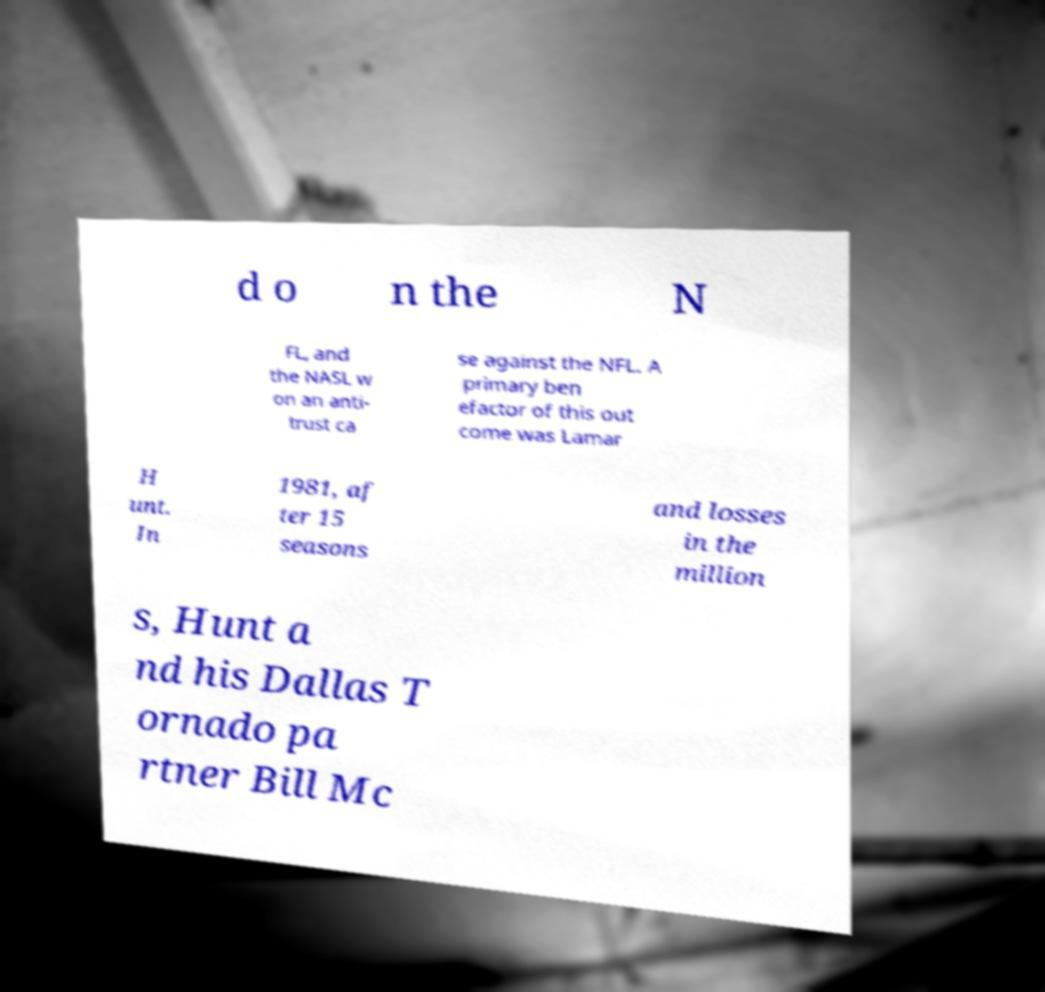Could you extract and type out the text from this image? d o n the N FL, and the NASL w on an anti- trust ca se against the NFL. A primary ben efactor of this out come was Lamar H unt. In 1981, af ter 15 seasons and losses in the million s, Hunt a nd his Dallas T ornado pa rtner Bill Mc 